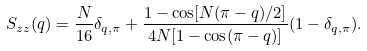<formula> <loc_0><loc_0><loc_500><loc_500>S _ { z z } ( q ) = \frac { N } { 1 6 } \delta _ { q , \pi } + \frac { 1 - \cos [ N ( \pi - q ) / 2 ] } { 4 N [ 1 - \cos ( \pi - q ) ] } ( 1 - \delta _ { q , \pi } ) .</formula> 